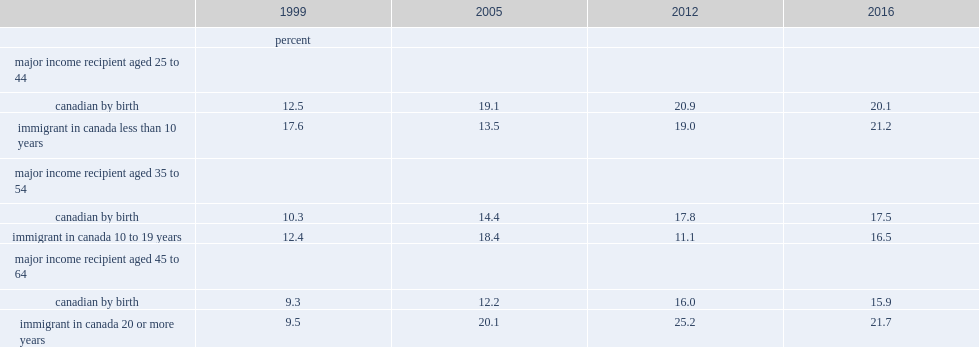What are the percentages of older immigrant families whose major income recipients were aged 45 to 64 with no financial welth in 1999? 9.5. 